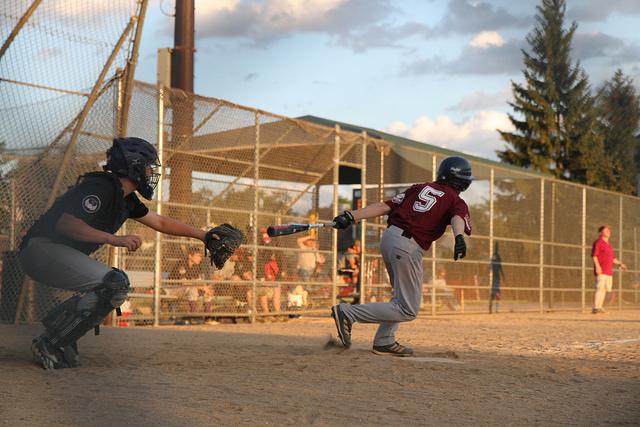What number is on the players shirt?
Write a very short answer. 5. Who is the behind the boy with the bat?
Answer briefly. Catcher. Which sport is this?
Answer briefly. Baseball. 